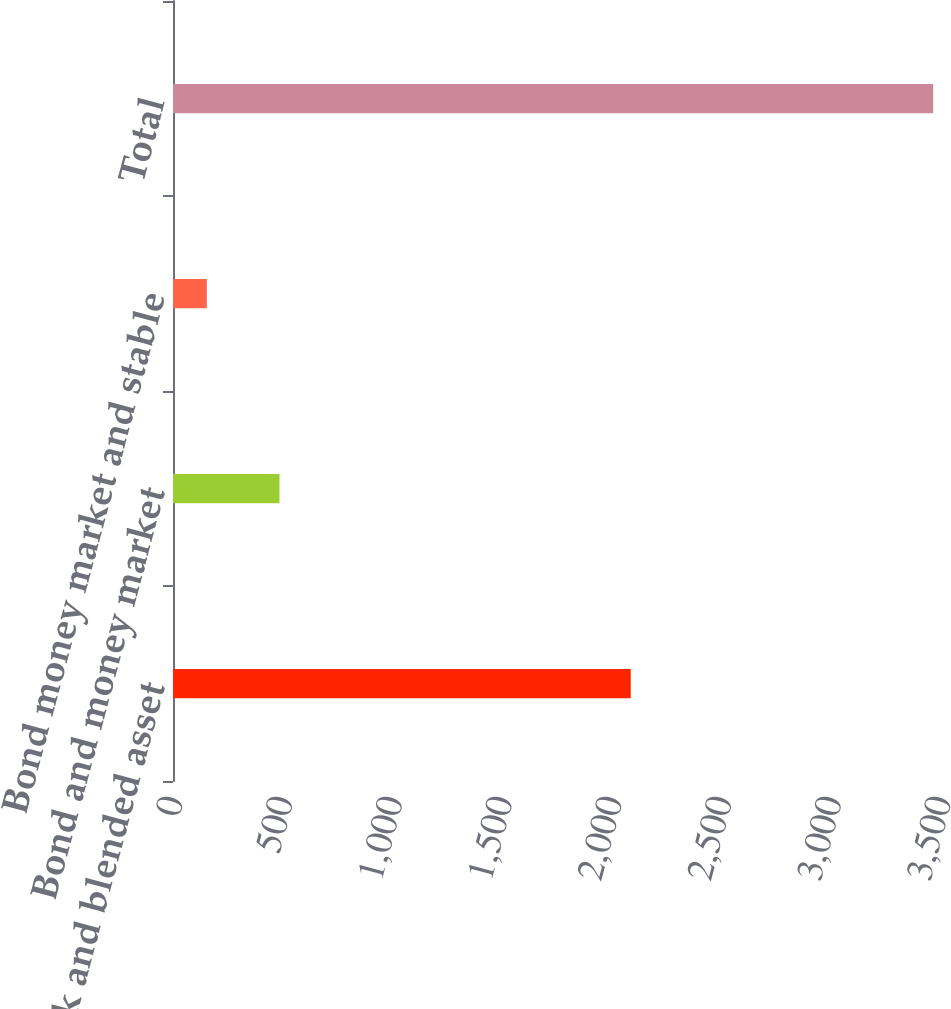Convert chart to OTSL. <chart><loc_0><loc_0><loc_500><loc_500><bar_chart><fcel>Stock and blended asset<fcel>Bond and money market<fcel>Bond money market and stable<fcel>Total<nl><fcel>2086<fcel>485.23<fcel>154.2<fcel>3464.5<nl></chart> 